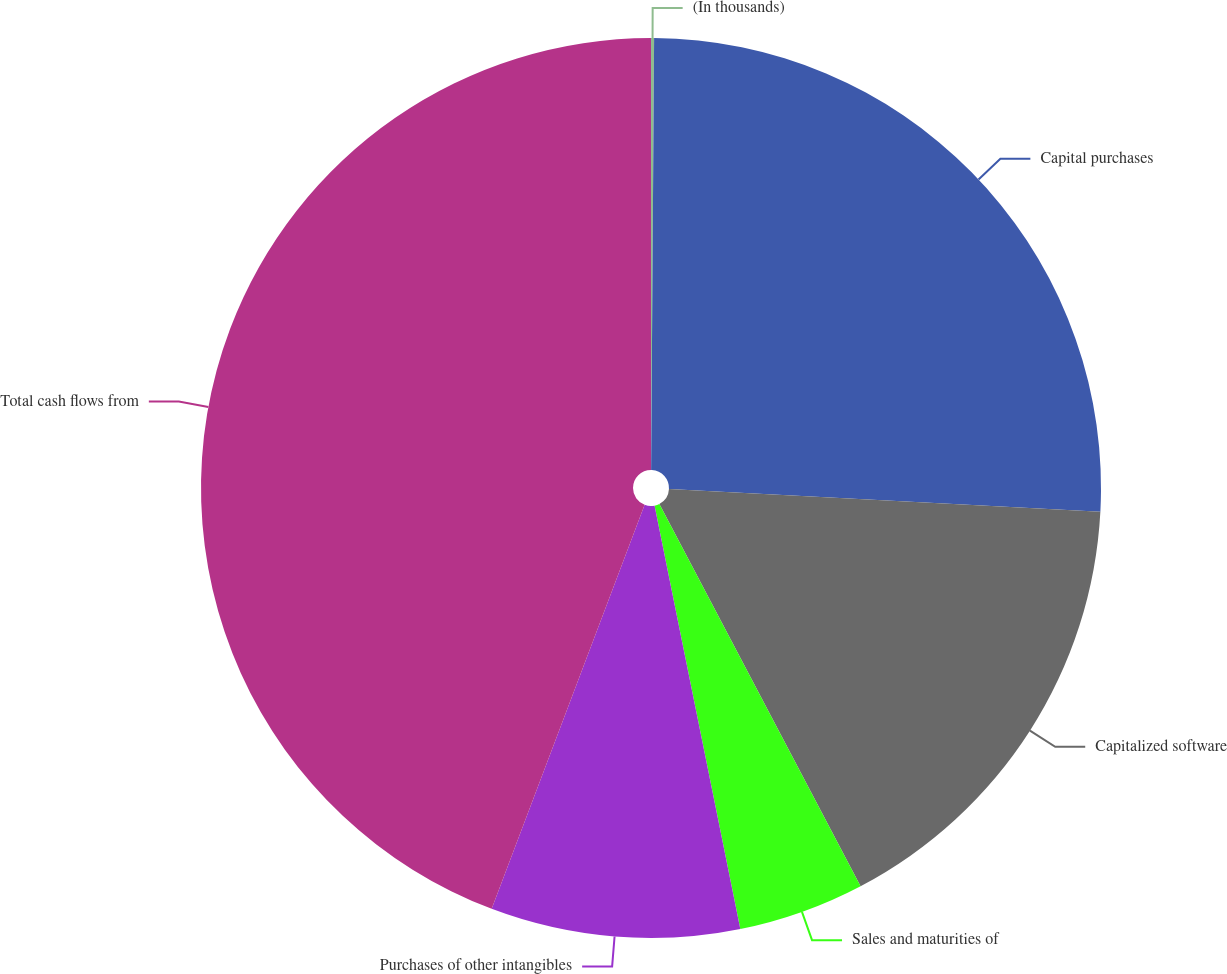Convert chart to OTSL. <chart><loc_0><loc_0><loc_500><loc_500><pie_chart><fcel>(In thousands)<fcel>Capital purchases<fcel>Capitalized software<fcel>Sales and maturities of<fcel>Purchases of other intangibles<fcel>Total cash flows from<nl><fcel>0.11%<fcel>25.73%<fcel>16.45%<fcel>4.53%<fcel>8.94%<fcel>44.24%<nl></chart> 